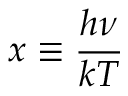<formula> <loc_0><loc_0><loc_500><loc_500>x \equiv \frac { h \nu } { k T }</formula> 